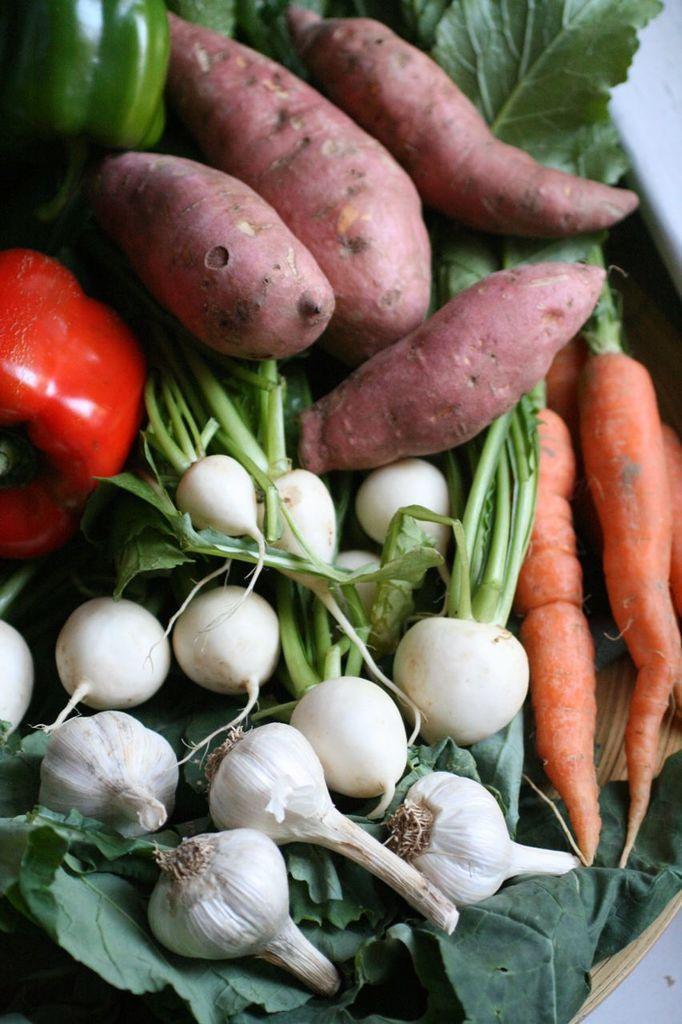How would you summarize this image in a sentence or two? In this image inside a basket there are garlic, carrots, sweet potato, bell peppers , other vegetables are there. 